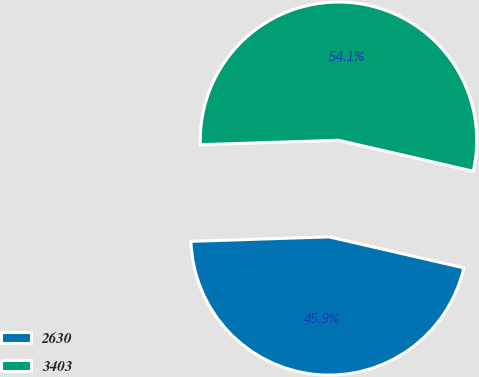Convert chart to OTSL. <chart><loc_0><loc_0><loc_500><loc_500><pie_chart><fcel>2630<fcel>3403<nl><fcel>45.89%<fcel>54.11%<nl></chart> 